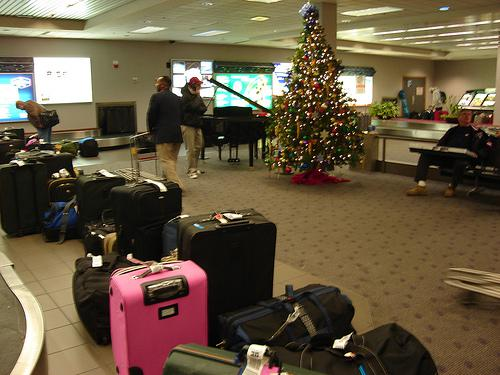Question: how many Christmas trees are there?
Choices:
A. 1.
B. 5.
C. 2.
D. 3.
Answer with the letter. Answer: A Question: what kind of tree is there?
Choices:
A. Pine.
B. Magnolia.
C. Christmas.
D. Oak.
Answer with the letter. Answer: C Question: where is the Christmas tree?
Choices:
A. The mall.
B. Airport terminal.
C. In the house.
D. The store.
Answer with the letter. Answer: B Question: what is glowing on the tree?
Choices:
A. Lights.
B. Candles.
C. Ornaments.
D. Mirrored balls.
Answer with the letter. Answer: A Question: what instrument is next to the tree?
Choices:
A. Drums.
B. Clarinet.
C. Piano.
D. Violin.
Answer with the letter. Answer: C 